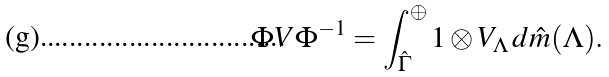Convert formula to latex. <formula><loc_0><loc_0><loc_500><loc_500>\Phi V \Phi ^ { - 1 } = \int _ { \hat { \Gamma } } ^ { \oplus } 1 \otimes V _ { \Lambda } \, d \hat { m } ( \Lambda ) .</formula> 